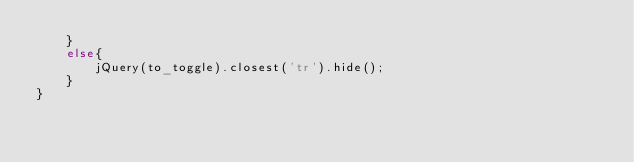<code> <loc_0><loc_0><loc_500><loc_500><_JavaScript_>	}
	else{
		jQuery(to_toggle).closest('tr').hide();
	}
}</code> 